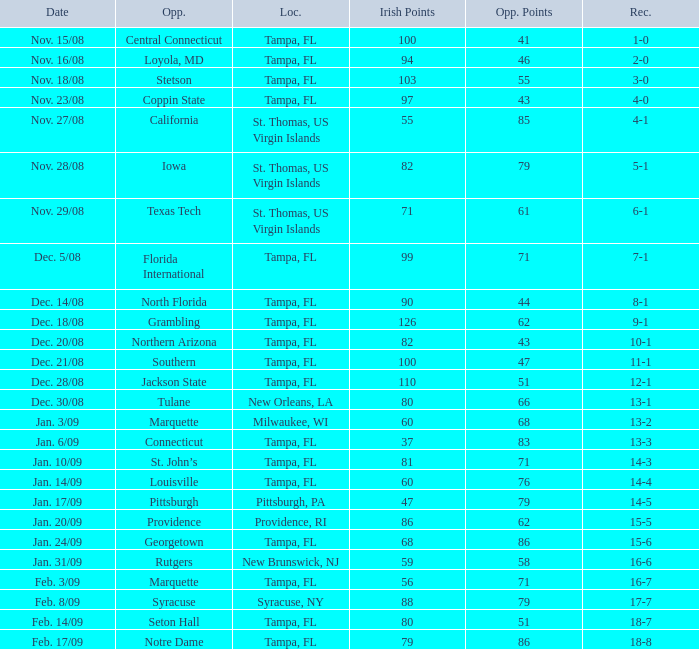What is the record where the locaiton is tampa, fl and the opponent is louisville? 14-4. 